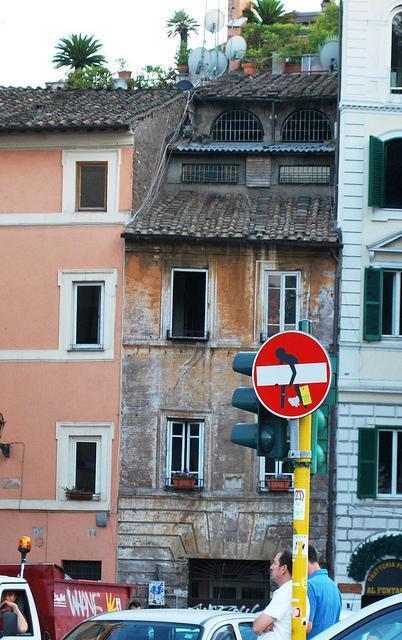How many windows do you see on the pink building?
Give a very brief answer. 3. How many cars are in the picture?
Give a very brief answer. 2. How many apple iphones are there?
Give a very brief answer. 0. 